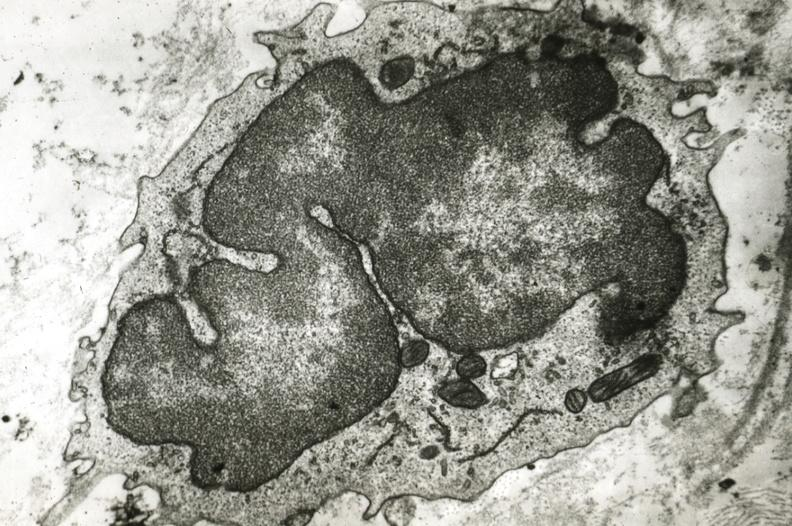s cardiovascular present?
Answer the question using a single word or phrase. Yes 